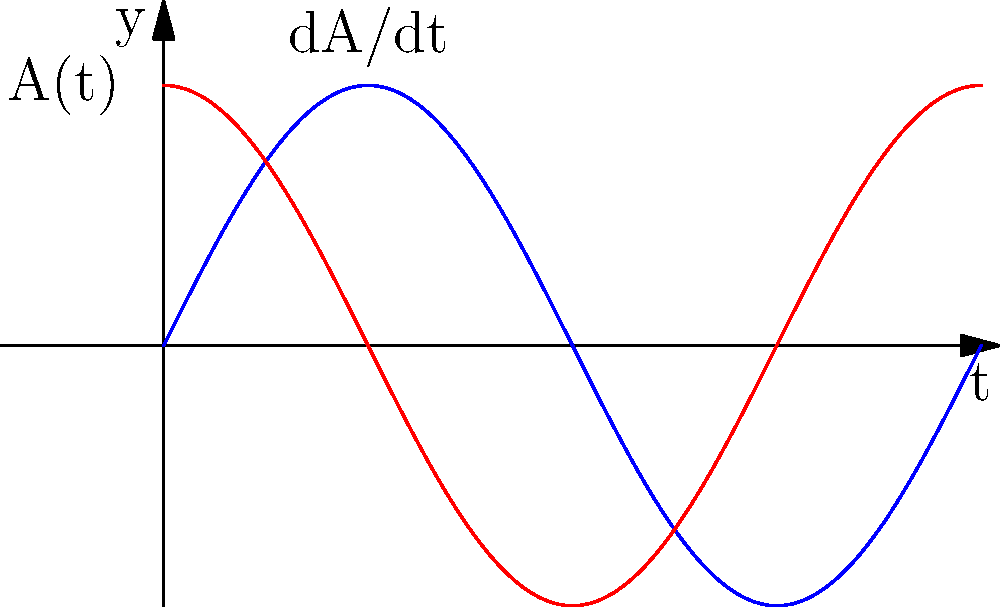Consider a sine wave with amplitude $A(t) = 2\sin(t)$. Calculate the rate of change of the amplitude with respect to time at $t = \frac{\pi}{4}$. To solve this problem, we need to follow these steps:

1) The amplitude function is given as $A(t) = 2\sin(t)$.

2) To find the rate of change of amplitude with respect to time, we need to differentiate $A(t)$ with respect to $t$:

   $$\frac{dA}{dt} = 2\cos(t)$$

3) Now, we need to evaluate this derivative at $t = \frac{\pi}{4}$:

   $$\frac{dA}{dt}\bigg|_{t=\frac{\pi}{4}} = 2\cos(\frac{\pi}{4})$$

4) Recall that $\cos(\frac{\pi}{4}) = \frac{\sqrt{2}}{2}$:

   $$\frac{dA}{dt}\bigg|_{t=\frac{\pi}{4}} = 2 \cdot \frac{\sqrt{2}}{2} = \sqrt{2}$$

Therefore, the rate of change of the amplitude at $t = \frac{\pi}{4}$ is $\sqrt{2}$.
Answer: $\sqrt{2}$ 